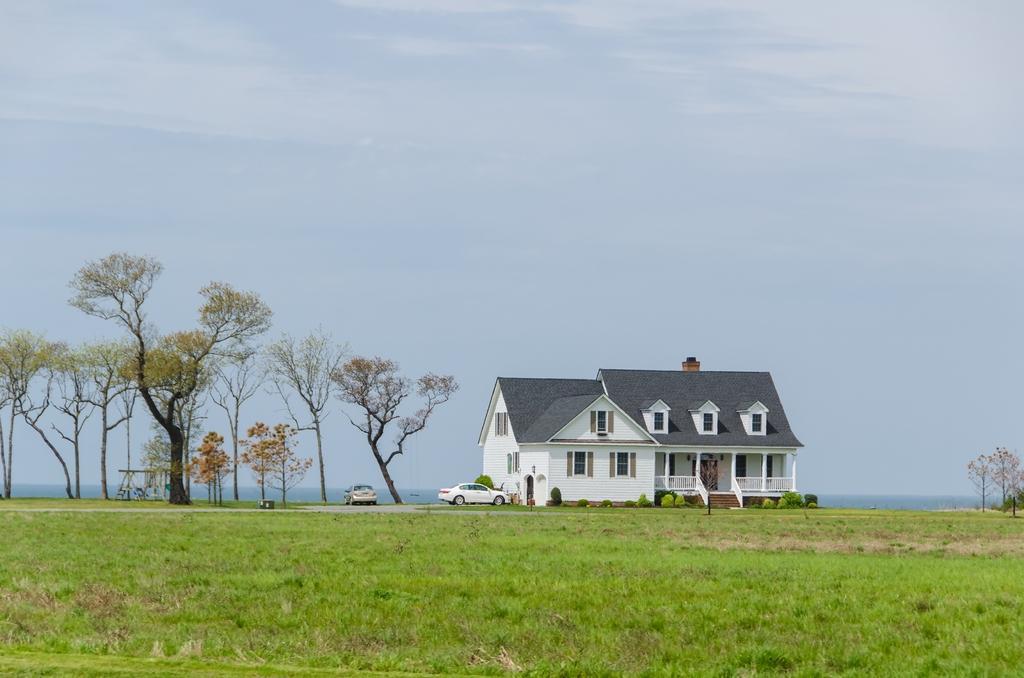Could you give a brief overview of what you see in this image? In this image in the center there is one house, and also there are some cars, plants, trees. At the bottom there is grass, and on the left side there is swing. And in the background there are mountains, at the top there is sky. 